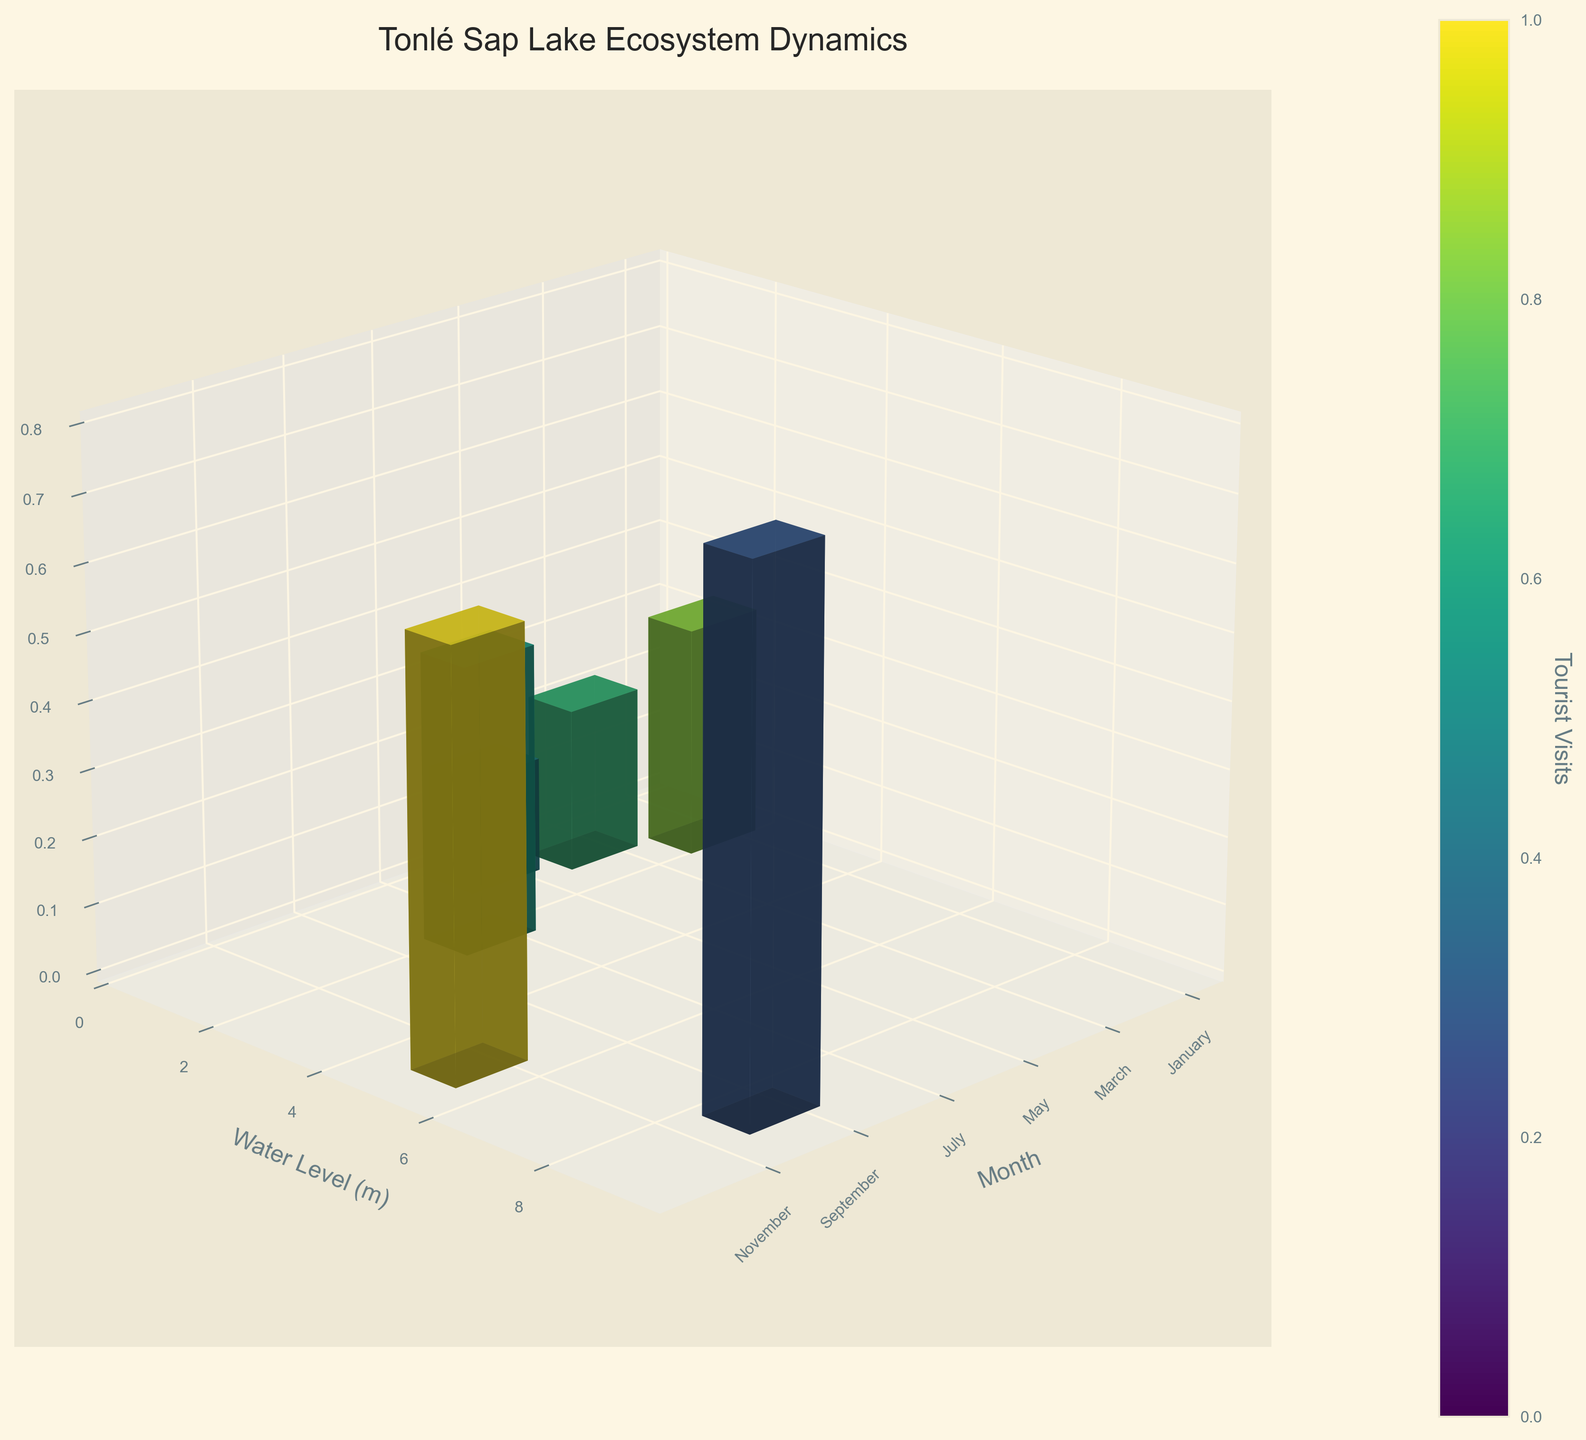What is the title of the figure? The title of the figure is displayed at the top and summarizes the main topic being visualized.
Answer: Tonlé Sap Lake Ecosystem Dynamics What does the color of the bars represent? According to the figure, the color scale on the bars denotes a specific variable. The color bar legend indicates what this variable is.
Answer: Tourist Visits In which month is the water level the highest? Water levels are represented on the Y-axis, and each month's data is plotted. The month corresponding to the highest value on the Y-axis is the answer.
Answer: September What’s the average water level across all the months? To find the average, sum all the water levels and then divide by the number of months: (1.5 + 0.8 + 0.5 + 2.0 + 8.5 + 5.0) / 6.
Answer: 3.05 meters Which month has the least number of fish species? Fish species count is represented on the Z-axis. By analyzing the bars' heights, identify the month with the lowest bar in the Z-dimension.
Answer: May How does the fish species count in July compare with that in November? Compare the heights of the bars for July and November along the Z-axis.
Answer: July has fewer fish species than November In terms of tourist visits, which month stands out the most? Tourist visit numbers are represented by the color of the bars. The month with the most distinct or intense color relative to the others stands out.
Answer: November What is the water level difference between January and May? Subtract the water level value of May from that of January using the values on the Y-axis.
Answer: 1.0 meters Which month experiences the greatest tourist influx and the least water level? By examining the color scale and the height of bars on the Y-axis, determine the respective months.
Answer: November and May 